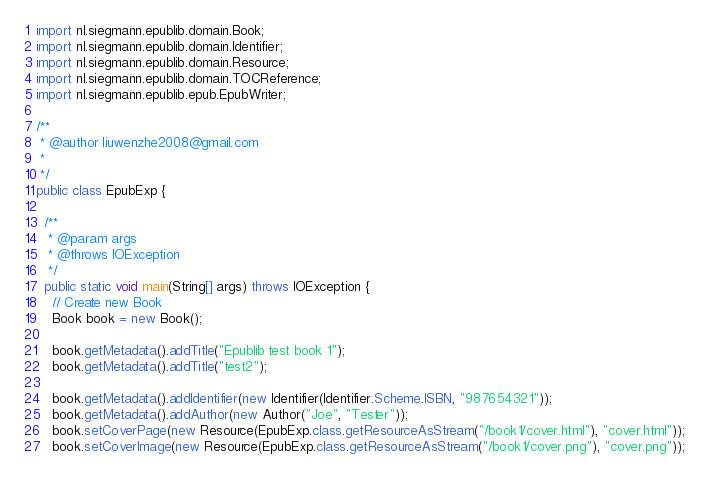Convert code to text. <code><loc_0><loc_0><loc_500><loc_500><_Java_>import nl.siegmann.epublib.domain.Book;
import nl.siegmann.epublib.domain.Identifier;
import nl.siegmann.epublib.domain.Resource;
import nl.siegmann.epublib.domain.TOCReference;
import nl.siegmann.epublib.epub.EpubWriter;

/**
 * @author liuwenzhe2008@gmail.com
 *
 */
public class EpubExp {

  /**
   * @param args
   * @throws IOException 
   */
  public static void main(String[] args) throws IOException {
    // Create new Book
    Book book = new Book();

    book.getMetadata().addTitle("Epublib test book 1");
    book.getMetadata().addTitle("test2");

    book.getMetadata().addIdentifier(new Identifier(Identifier.Scheme.ISBN, "987654321"));
    book.getMetadata().addAuthor(new Author("Joe", "Tester"));
    book.setCoverPage(new Resource(EpubExp.class.getResourceAsStream("/book1/cover.html"), "cover.html"));
    book.setCoverImage(new Resource(EpubExp.class.getResourceAsStream("/book1/cover.png"), "cover.png"));</code> 